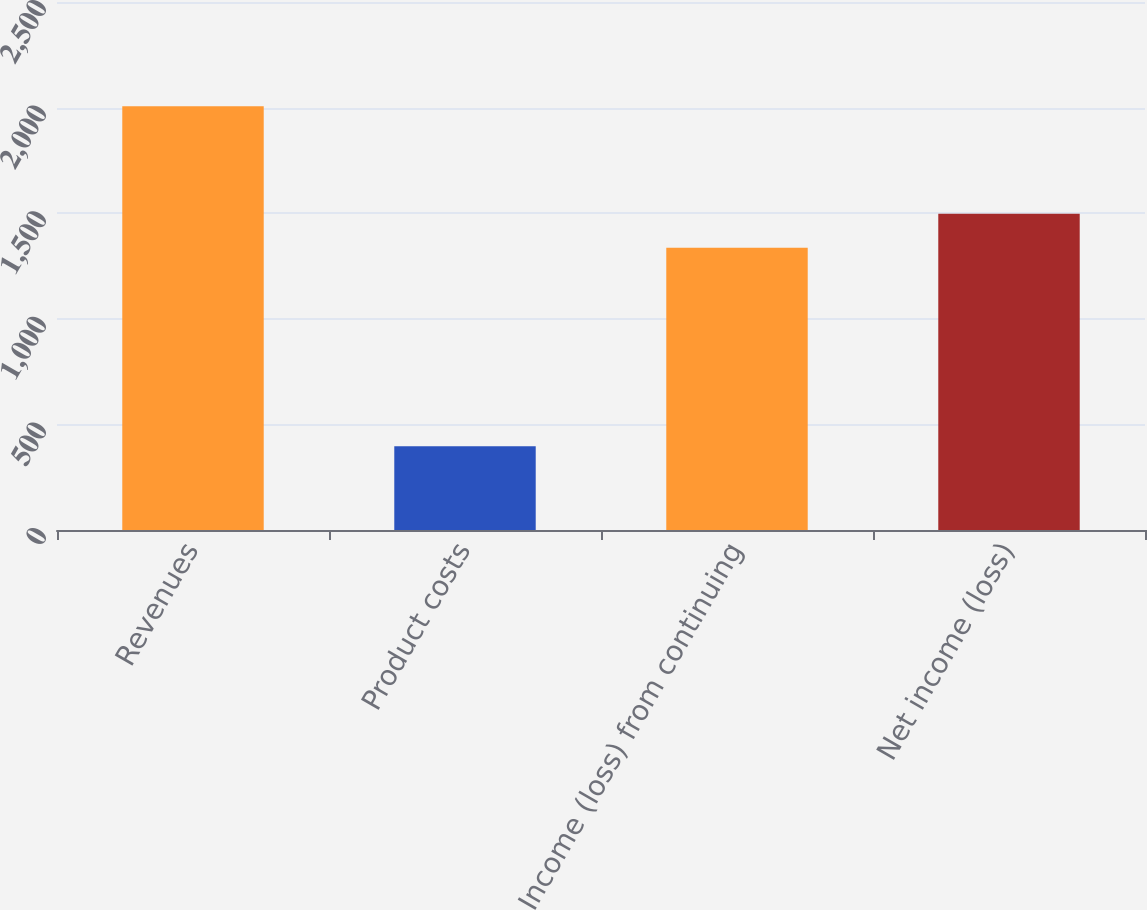Convert chart to OTSL. <chart><loc_0><loc_0><loc_500><loc_500><bar_chart><fcel>Revenues<fcel>Product costs<fcel>Income (loss) from continuing<fcel>Net income (loss)<nl><fcel>2006<fcel>397<fcel>1337<fcel>1497.9<nl></chart> 